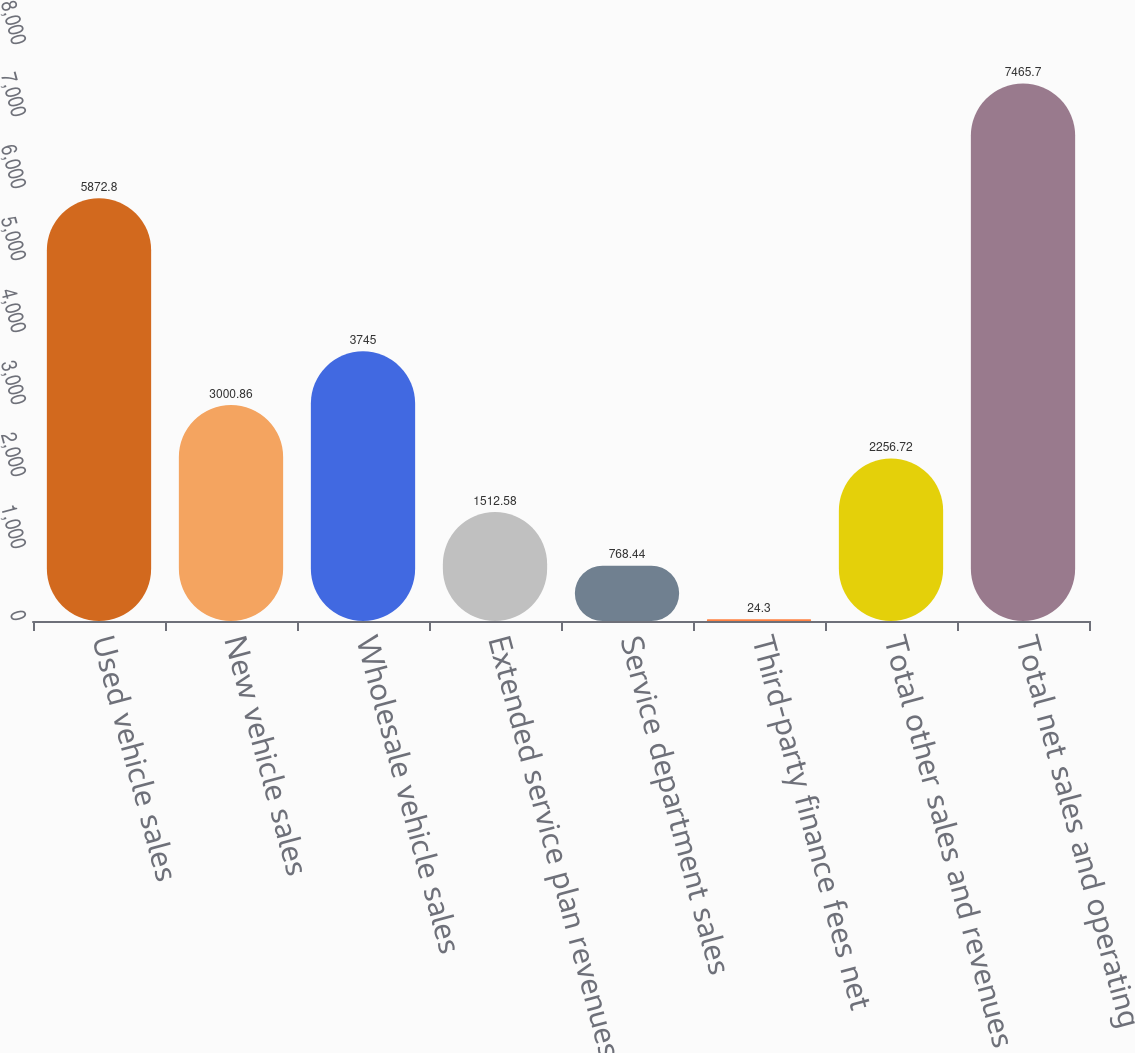<chart> <loc_0><loc_0><loc_500><loc_500><bar_chart><fcel>Used vehicle sales<fcel>New vehicle sales<fcel>Wholesale vehicle sales<fcel>Extended service plan revenues<fcel>Service department sales<fcel>Third-party finance fees net<fcel>Total other sales and revenues<fcel>Total net sales and operating<nl><fcel>5872.8<fcel>3000.86<fcel>3745<fcel>1512.58<fcel>768.44<fcel>24.3<fcel>2256.72<fcel>7465.7<nl></chart> 